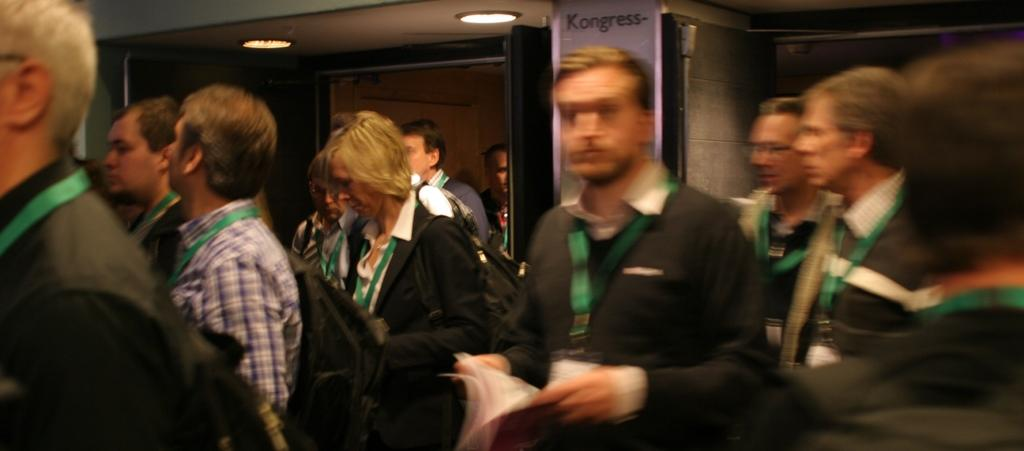How many people are in the image? There is a group of people in the image. What can be seen in the image that provides illumination? There is a light visible in the image. What architectural feature is present in the image? There is a door in the image. What type of structure is depicted in the image? There is a wall in the image. How many mice are running around on the wall in the image? There are no mice present in the image; it only features a group of people, a light, a door, and a wall. What type of society is depicted in the image? The image does not depict a society; it only shows a group of people, a light, a door, and a wall. 